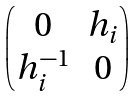<formula> <loc_0><loc_0><loc_500><loc_500>\begin{pmatrix} 0 & h _ { i } \\ h _ { i } ^ { - 1 } & 0 \end{pmatrix}</formula> 